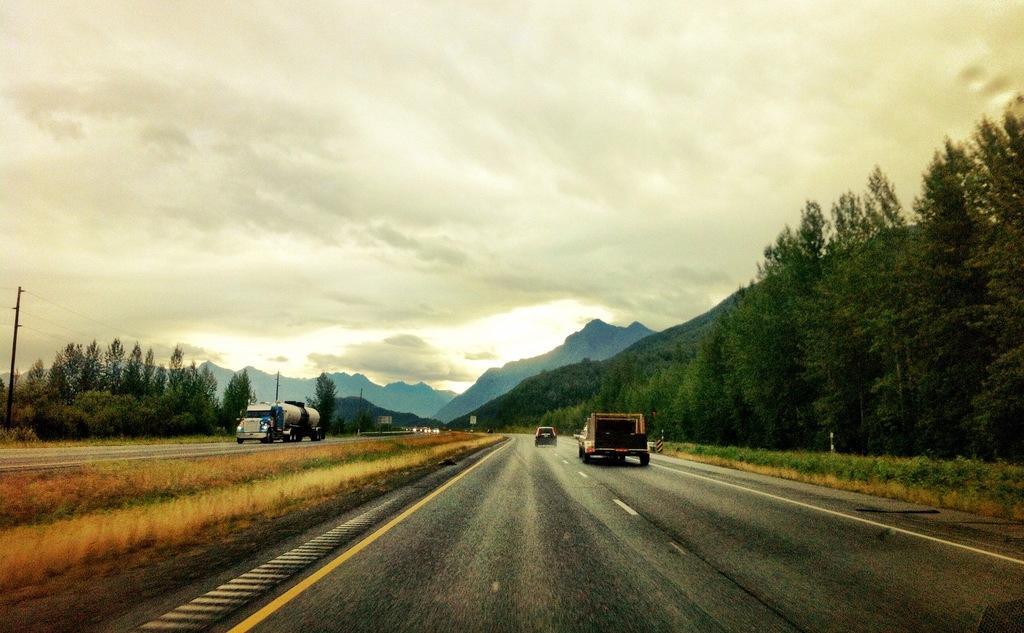Can you describe this image briefly? There is a road and on the either side of the road there are many tees and in the background there is a mountain. 